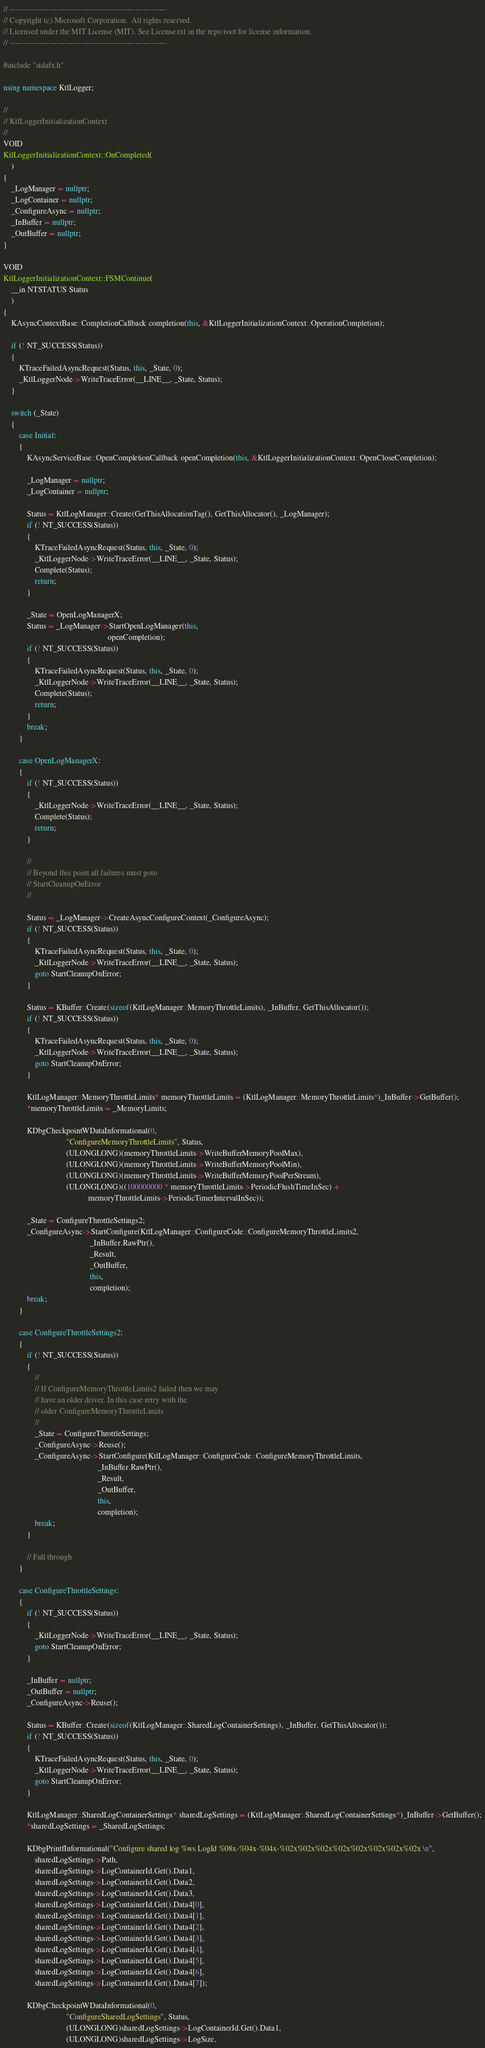<code> <loc_0><loc_0><loc_500><loc_500><_C++_>// ------------------------------------------------------------
// Copyright (c) Microsoft Corporation.  All rights reserved.
// Licensed under the MIT License (MIT). See License.txt in the repo root for license information.
// ------------------------------------------------------------

#include "stdafx.h"

using namespace KtlLogger;

//
// KtlLoggerInitializationContext
//
VOID
KtlLoggerInitializationContext::OnCompleted(
    )
{
    _LogManager = nullptr;
    _LogContainer = nullptr;
    _ConfigureAsync = nullptr;
    _InBuffer = nullptr;
    _OutBuffer = nullptr;
}

VOID
KtlLoggerInitializationContext::FSMContinue(
    __in NTSTATUS Status
    )
{
    KAsyncContextBase::CompletionCallback completion(this, &KtlLoggerInitializationContext::OperationCompletion);

    if (! NT_SUCCESS(Status))
    {
        KTraceFailedAsyncRequest(Status, this, _State, 0);
        _KtlLoggerNode->WriteTraceError(__LINE__, _State, Status);
    }

    switch (_State)
    {
        case Initial:
        {
            KAsyncServiceBase::OpenCompletionCallback openCompletion(this, &KtlLoggerInitializationContext::OpenCloseCompletion);

            _LogManager = nullptr;
            _LogContainer = nullptr;

            Status = KtlLogManager::Create(GetThisAllocationTag(), GetThisAllocator(), _LogManager);
            if (! NT_SUCCESS(Status))
            {               
                KTraceFailedAsyncRequest(Status, this, _State, 0);
                _KtlLoggerNode->WriteTraceError(__LINE__, _State, Status);
                Complete(Status);
                return;
            }

            _State = OpenLogManagerX;
            Status = _LogManager->StartOpenLogManager(this,
                                                     openCompletion);
            if (! NT_SUCCESS(Status))
            {               
                KTraceFailedAsyncRequest(Status, this, _State, 0);
                _KtlLoggerNode->WriteTraceError(__LINE__, _State, Status);
                Complete(Status);
                return;
            }
            break;
        }
        
        case OpenLogManagerX:
        {
            if (! NT_SUCCESS(Status))
            {
                _KtlLoggerNode->WriteTraceError(__LINE__, _State, Status);
                Complete(Status);
                return;
            }

            //
            // Beyond this point all failures must goto
            // StartCleanupOnError
            //
            
            Status = _LogManager->CreateAsyncConfigureContext(_ConfigureAsync);
            if (! NT_SUCCESS(Status))
            {               
                KTraceFailedAsyncRequest(Status, this, _State, 0);              
                _KtlLoggerNode->WriteTraceError(__LINE__, _State, Status);
                goto StartCleanupOnError;
            }

            Status = KBuffer::Create(sizeof(KtlLogManager::MemoryThrottleLimits), _InBuffer, GetThisAllocator());
            if (! NT_SUCCESS(Status))
            {               
                KTraceFailedAsyncRequest(Status, this, _State, 0);
                _KtlLoggerNode->WriteTraceError(__LINE__, _State, Status);
                goto StartCleanupOnError;
            }
            
            KtlLogManager::MemoryThrottleLimits* memoryThrottleLimits = (KtlLogManager::MemoryThrottleLimits*)_InBuffer->GetBuffer();
            *memoryThrottleLimits = _MemoryLimits;

            KDbgCheckpointWDataInformational(0,
                                "ConfigureMemoryThrottleLimits", Status,
                                (ULONGLONG)(memoryThrottleLimits->WriteBufferMemoryPoolMax),
                                (ULONGLONG)(memoryThrottleLimits->WriteBufferMemoryPoolMin),
                                (ULONGLONG)(memoryThrottleLimits->WriteBufferMemoryPoolPerStream),
                                (ULONGLONG)((100000000 * memoryThrottleLimits->PeriodicFlushTimeInSec) +
                                           memoryThrottleLimits->PeriodicTimerIntervalInSec));
            
            _State = ConfigureThrottleSettings2;
            _ConfigureAsync->StartConfigure(KtlLogManager::ConfigureCode::ConfigureMemoryThrottleLimits2,
                                            _InBuffer.RawPtr(),
                                            _Result,
                                            _OutBuffer,
                                            this,
                                            completion);
            break;
        }

        case ConfigureThrottleSettings2:
        {
            if (! NT_SUCCESS(Status))
            {
                //
                // If ConfigureMemoryThrottleLimits2 failed then we may
                // have an older driver. In this case retry with the
                // older ConfigureMemoryThrottleLimits
                //
                _State = ConfigureThrottleSettings;
                _ConfigureAsync->Reuse();
                _ConfigureAsync->StartConfigure(KtlLogManager::ConfigureCode::ConfigureMemoryThrottleLimits,
                                                _InBuffer.RawPtr(),
                                                _Result,
                                                _OutBuffer,
                                                this,
                                                completion);
                break;
            }
            
            // Fall through
        }
        
        case ConfigureThrottleSettings:
        {
            if (! NT_SUCCESS(Status))
            {               
                _KtlLoggerNode->WriteTraceError(__LINE__, _State, Status);
                goto StartCleanupOnError;
            }
            
            _InBuffer = nullptr;
            _OutBuffer = nullptr;
            _ConfigureAsync->Reuse();
            
            Status = KBuffer::Create(sizeof(KtlLogManager::SharedLogContainerSettings), _InBuffer, GetThisAllocator());
            if (! NT_SUCCESS(Status))
            {               
                KTraceFailedAsyncRequest(Status, this, _State, 0);
                _KtlLoggerNode->WriteTraceError(__LINE__, _State, Status);
                goto StartCleanupOnError;
            }

            KtlLogManager::SharedLogContainerSettings* sharedLogSettings = (KtlLogManager::SharedLogContainerSettings*)_InBuffer->GetBuffer();
            *sharedLogSettings = _SharedLogSettings;            

            KDbgPrintfInformational("Configure shared log %ws LogId %08x-%04x-%04x-%02x%02x%02x%02x%02x%02x%02x%02x \n",
                sharedLogSettings->Path, 
                sharedLogSettings->LogContainerId.Get().Data1, 
                sharedLogSettings->LogContainerId.Get().Data2, 
                sharedLogSettings->LogContainerId.Get().Data3, 
                sharedLogSettings->LogContainerId.Get().Data4[0],
                sharedLogSettings->LogContainerId.Get().Data4[1],
                sharedLogSettings->LogContainerId.Get().Data4[2],
                sharedLogSettings->LogContainerId.Get().Data4[3],
                sharedLogSettings->LogContainerId.Get().Data4[4],
                sharedLogSettings->LogContainerId.Get().Data4[5],
                sharedLogSettings->LogContainerId.Get().Data4[6],
                sharedLogSettings->LogContainerId.Get().Data4[7]);
            
            KDbgCheckpointWDataInformational(0,
                                "ConfigureSharedLogSettings", Status,
                                (ULONGLONG)sharedLogSettings->LogContainerId.Get().Data1,
                                (ULONGLONG)sharedLogSettings->LogSize,</code> 